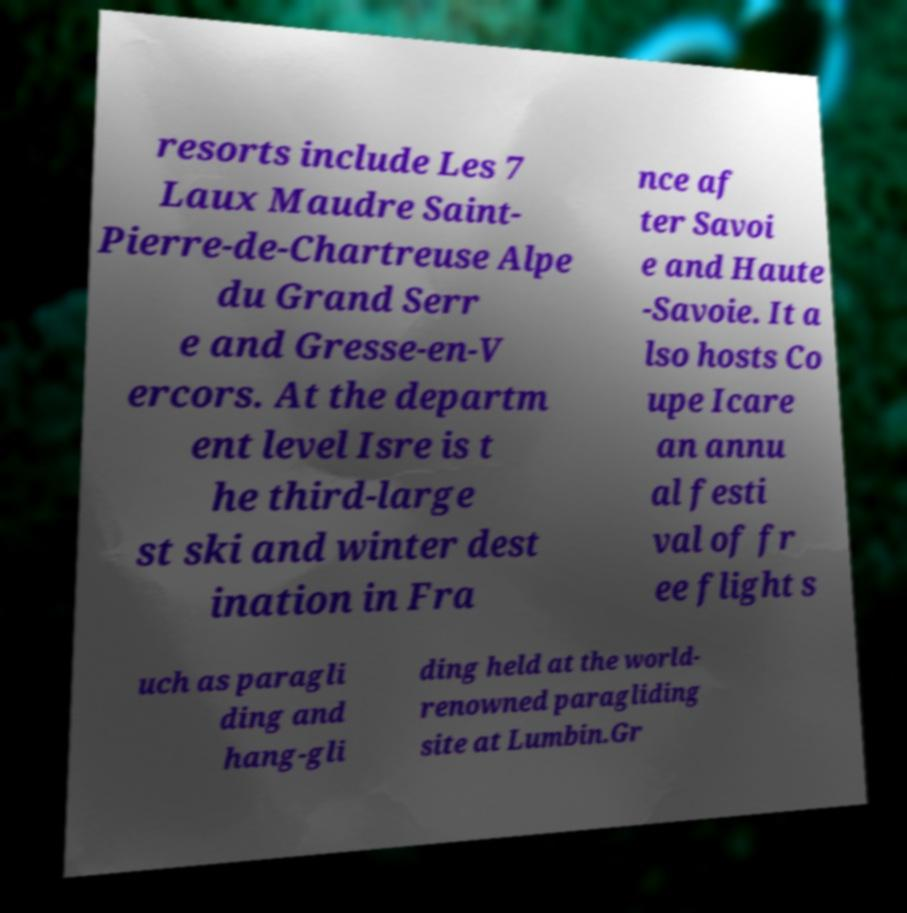Could you assist in decoding the text presented in this image and type it out clearly? resorts include Les 7 Laux Maudre Saint- Pierre-de-Chartreuse Alpe du Grand Serr e and Gresse-en-V ercors. At the departm ent level Isre is t he third-large st ski and winter dest ination in Fra nce af ter Savoi e and Haute -Savoie. It a lso hosts Co upe Icare an annu al festi val of fr ee flight s uch as paragli ding and hang-gli ding held at the world- renowned paragliding site at Lumbin.Gr 